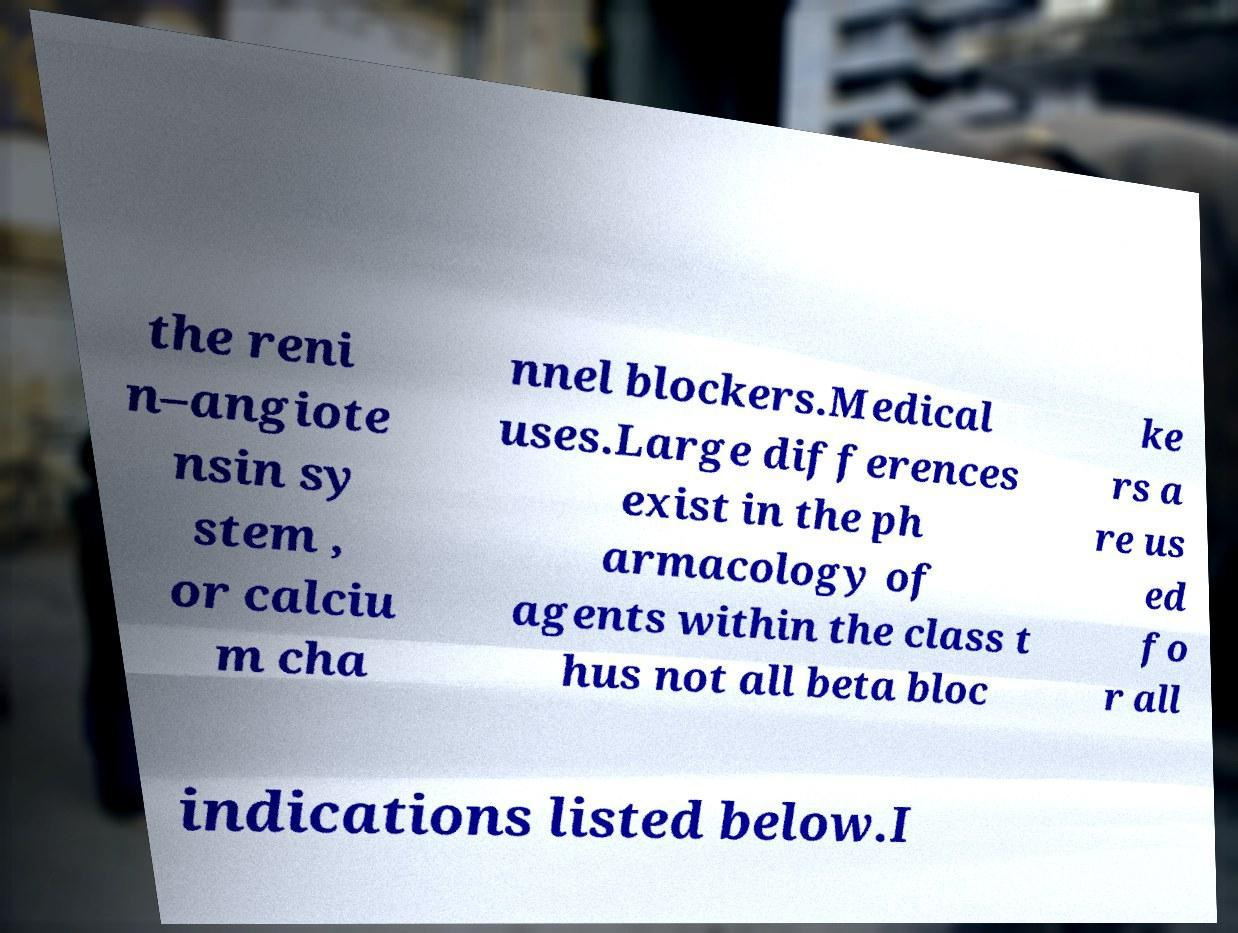For documentation purposes, I need the text within this image transcribed. Could you provide that? the reni n–angiote nsin sy stem , or calciu m cha nnel blockers.Medical uses.Large differences exist in the ph armacology of agents within the class t hus not all beta bloc ke rs a re us ed fo r all indications listed below.I 